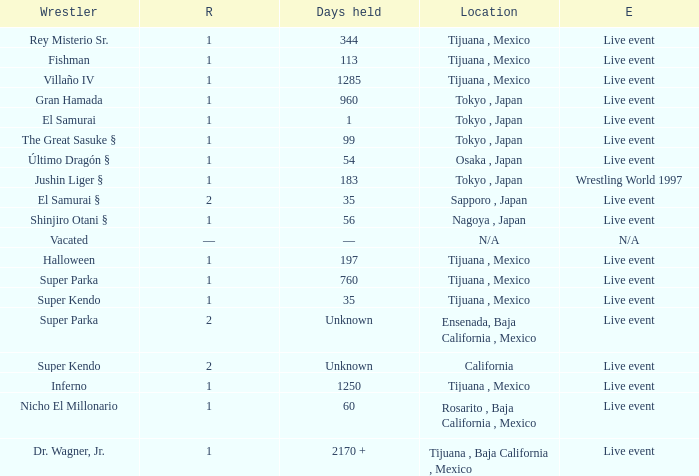Where did the wrestler, super parka, with the title with a reign of 2? Ensenada, Baja California , Mexico. 